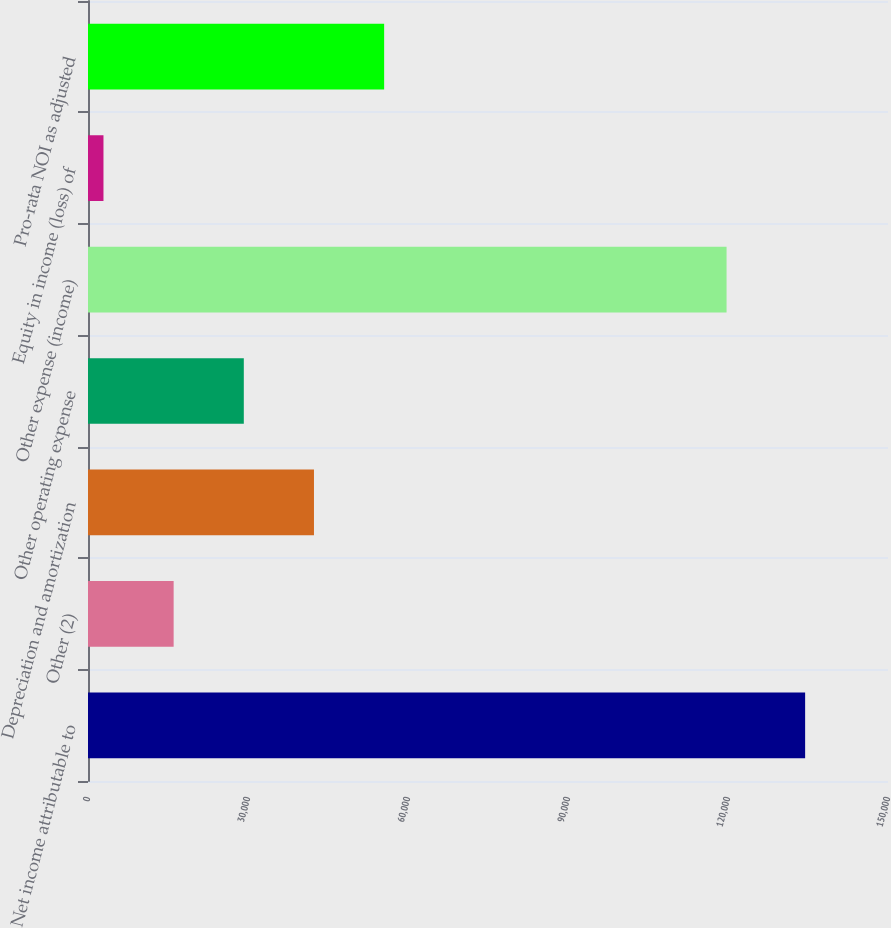Convert chart. <chart><loc_0><loc_0><loc_500><loc_500><bar_chart><fcel>Net income attributable to<fcel>Other (2)<fcel>Depreciation and amortization<fcel>Other operating expense<fcel>Other expense (income)<fcel>Equity in income (loss) of<fcel>Pro-rata NOI as adjusted<nl><fcel>134462<fcel>16058<fcel>42370<fcel>29214<fcel>119731<fcel>2902<fcel>55526<nl></chart> 